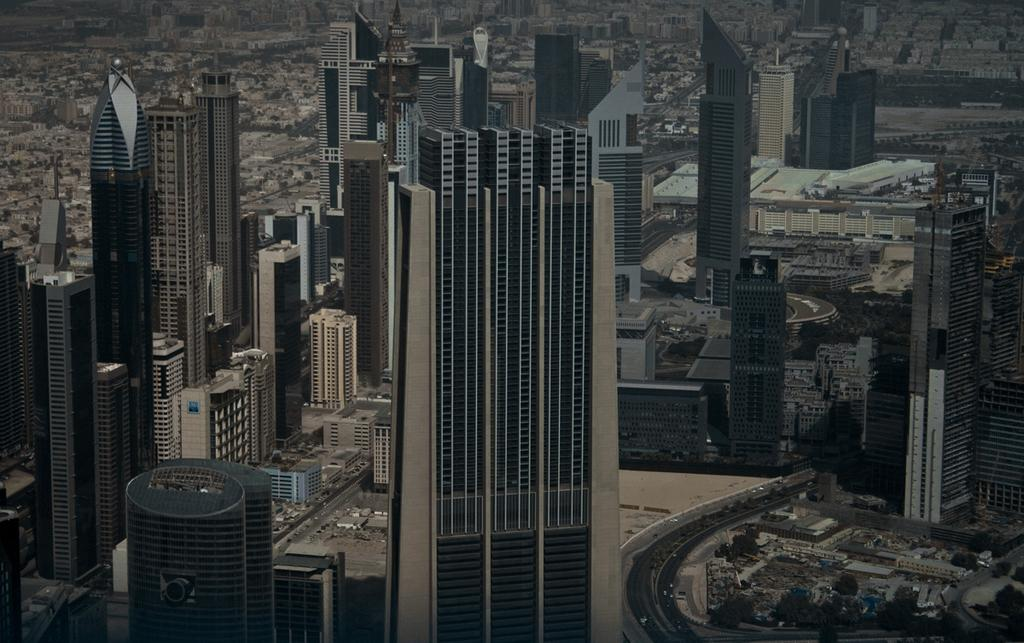What type of view is shown in the image? The image is a top view of a city. What structures can be seen in the image? There are buildings in the image. What connects the buildings in the image? There are roads in the image. What type of vehicles can be seen on the roads? There are cars in the image. What color is the sweater worn by the coach in the image? There is no sweater or coach present in the image; it is a top view of a city with buildings, roads, and cars. 